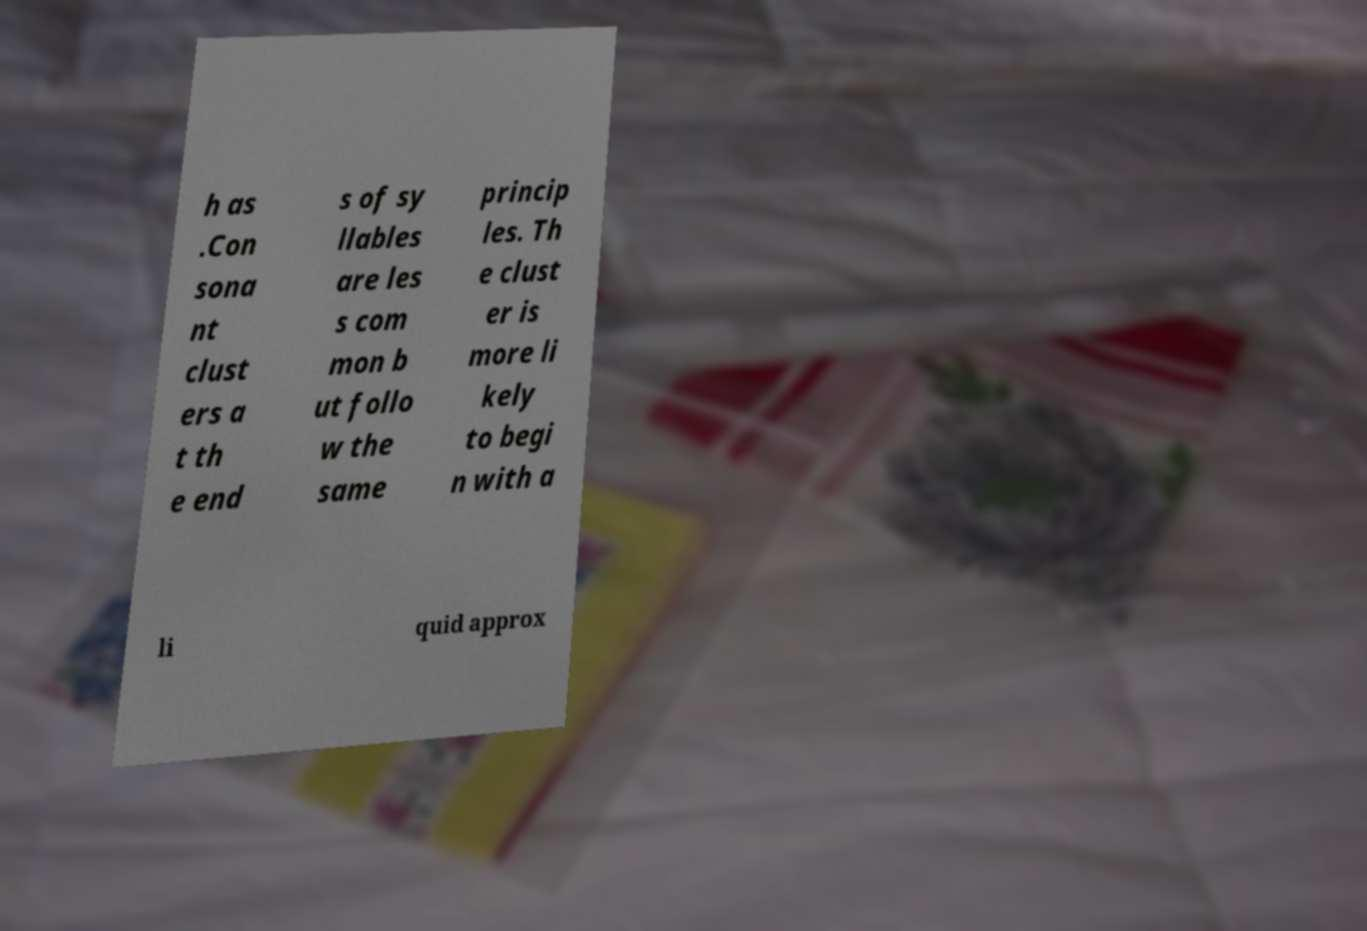Can you accurately transcribe the text from the provided image for me? h as .Con sona nt clust ers a t th e end s of sy llables are les s com mon b ut follo w the same princip les. Th e clust er is more li kely to begi n with a li quid approx 